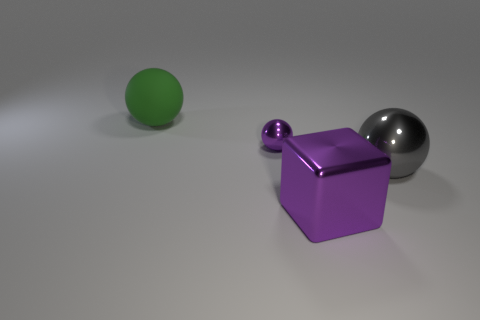What is the size of the other metal thing that is the same color as the tiny thing?
Offer a terse response. Large. Is there any other thing that is the same size as the purple metal ball?
Your answer should be compact. No. What size is the gray object?
Ensure brevity in your answer.  Large. Does the block have the same size as the metallic ball behind the large shiny sphere?
Provide a short and direct response. No. How many metal things are either blocks or gray objects?
Make the answer very short. 2. Are there fewer big metallic things that are left of the shiny cube than large balls that are in front of the large green object?
Keep it short and to the point. Yes. There is a shiny thing in front of the large sphere that is in front of the large green matte thing; are there any metallic balls left of it?
Provide a short and direct response. Yes. There is a large metal thing to the right of the big purple metal thing; is its shape the same as the large metal thing on the left side of the big shiny sphere?
Your response must be concise. No. There is a cube that is the same size as the gray metal sphere; what material is it?
Give a very brief answer. Metal. Is the material of the large ball that is behind the large gray shiny ball the same as the large ball that is to the right of the big rubber ball?
Offer a terse response. No. 